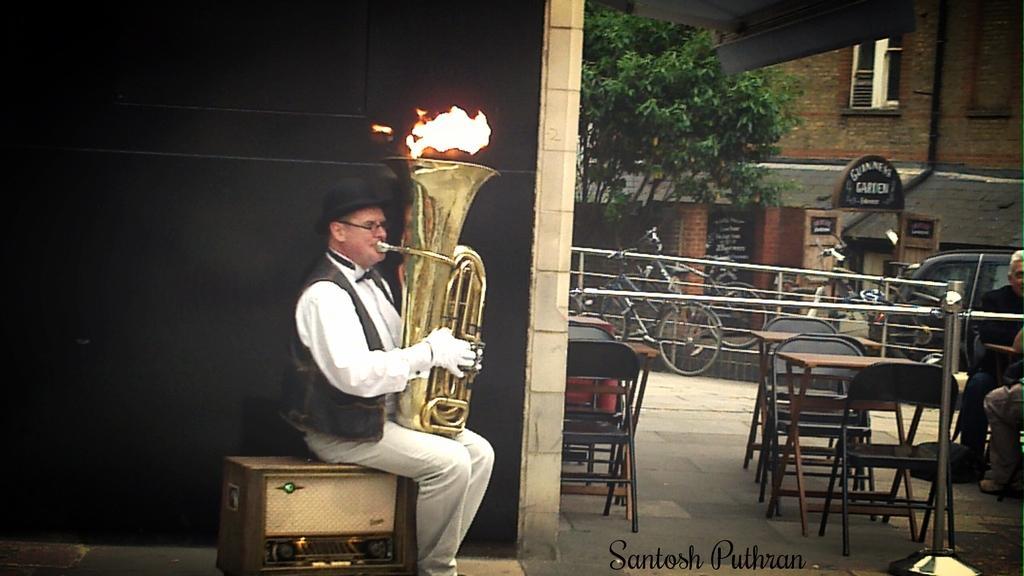How would you summarize this image in a sentence or two? The picture is taken outside of the building on the left corner of the picture there is one person sitting on the recorder he is in the white shirt playing some musical instrument, on the right corner of the picture two people are sitting on the chairs, there are chairs and tables behind them there are bicycles and one building and tree, there is one sign board. The person on the left corner is wearing hat and gloves. 